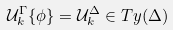Convert formula to latex. <formula><loc_0><loc_0><loc_500><loc_500>\mathcal { U } _ { k } ^ { \Gamma } \{ \phi \} = \mathcal { U } _ { k } ^ { \Delta } \in T y ( \Delta )</formula> 